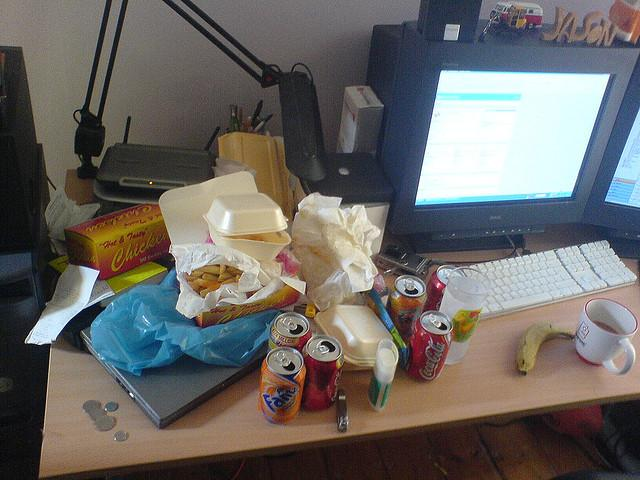Where is Coca-Cola's headquarters located? atlanta 